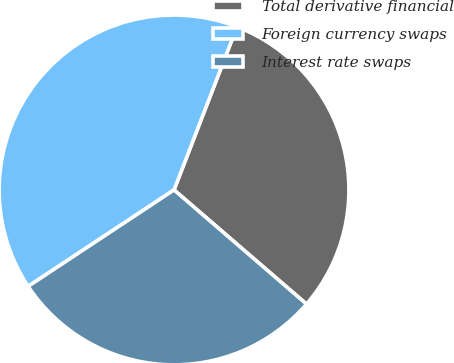Convert chart. <chart><loc_0><loc_0><loc_500><loc_500><pie_chart><fcel>Total derivative financial<fcel>Foreign currency swaps<fcel>Interest rate swaps<nl><fcel>30.46%<fcel>40.16%<fcel>29.38%<nl></chart> 